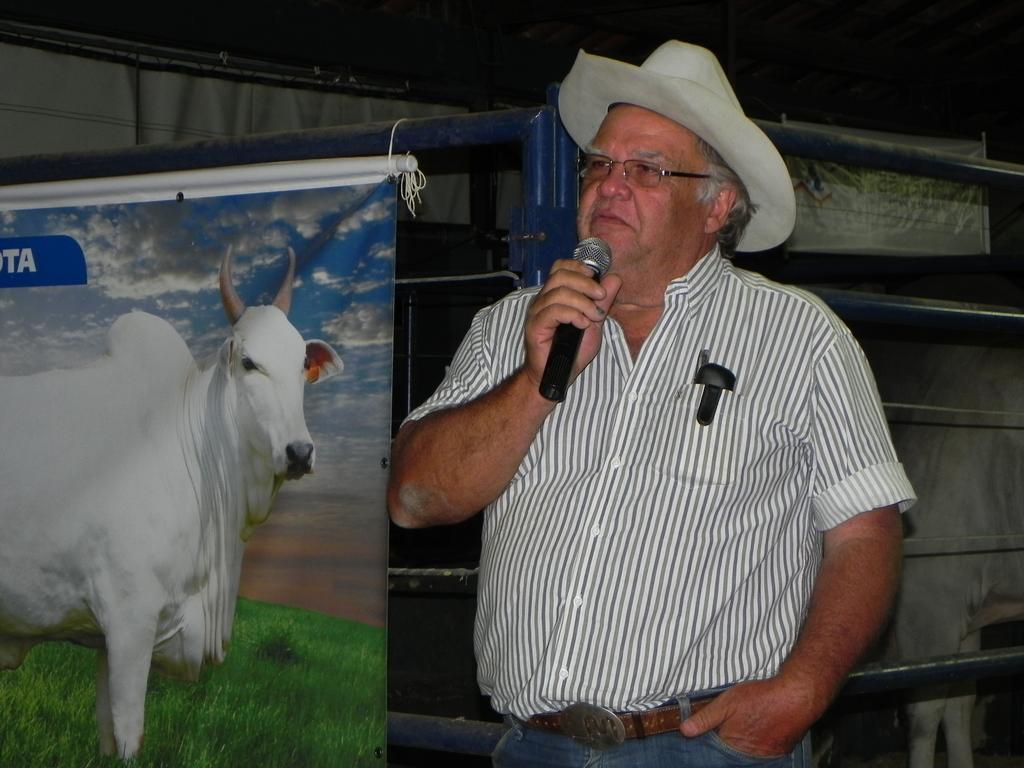What is the person in the image holding? The person is holding a microphone in the image. What can be seen on the posts in the image? The posts have images and text in the image. What type of objects are made of metal in the image? There are metal objects in the image. Can you describe the animal on the right side of the image? There is an animal on the right side of the image, but the specific type of animal cannot be determined from the provided facts. What type of chair is visible in the image? There is no chair present in the image. 